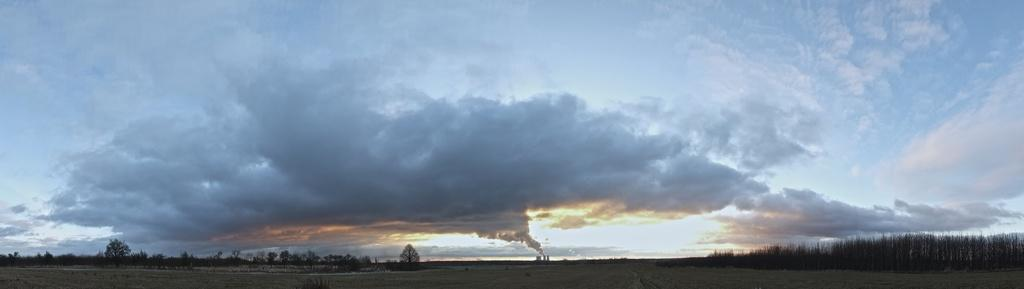What is happening with the outlet in the image? There is smoke coming out from an outlet in the image. What can be seen on the left side of the image? There are many trees on the left side of the image. What is visible in the background of the image? The sky is visible in the background of the image. Can you describe the sky in the image? The sky has heavy clouds in the image. How many balls are hanging from the trees in the image? There are no balls hanging from the trees in the image; there are only trees visible. What type of thread is being used to create the clouds in the image? There is no thread present in the image; the clouds are a natural part of the sky. 